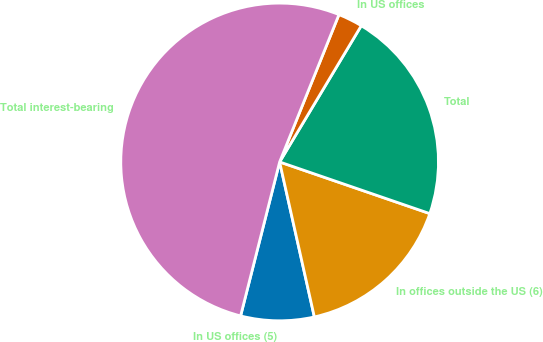Convert chart to OTSL. <chart><loc_0><loc_0><loc_500><loc_500><pie_chart><fcel>In US offices (5)<fcel>In offices outside the US (6)<fcel>Total<fcel>In US offices<fcel>Total interest-bearing<nl><fcel>7.46%<fcel>16.22%<fcel>21.68%<fcel>2.5%<fcel>52.14%<nl></chart> 